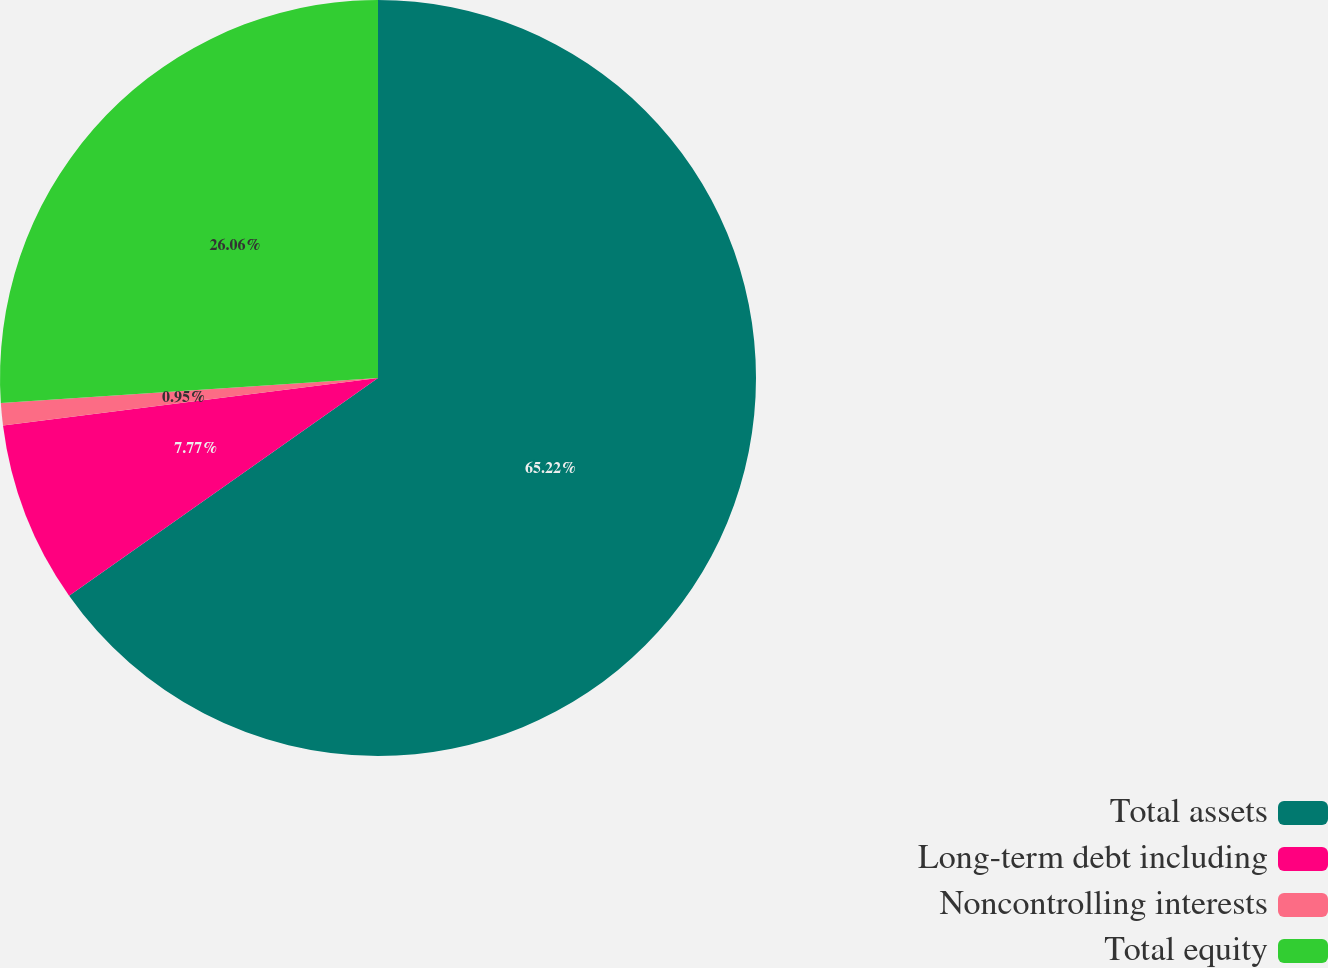Convert chart. <chart><loc_0><loc_0><loc_500><loc_500><pie_chart><fcel>Total assets<fcel>Long-term debt including<fcel>Noncontrolling interests<fcel>Total equity<nl><fcel>65.23%<fcel>7.77%<fcel>0.95%<fcel>26.06%<nl></chart> 